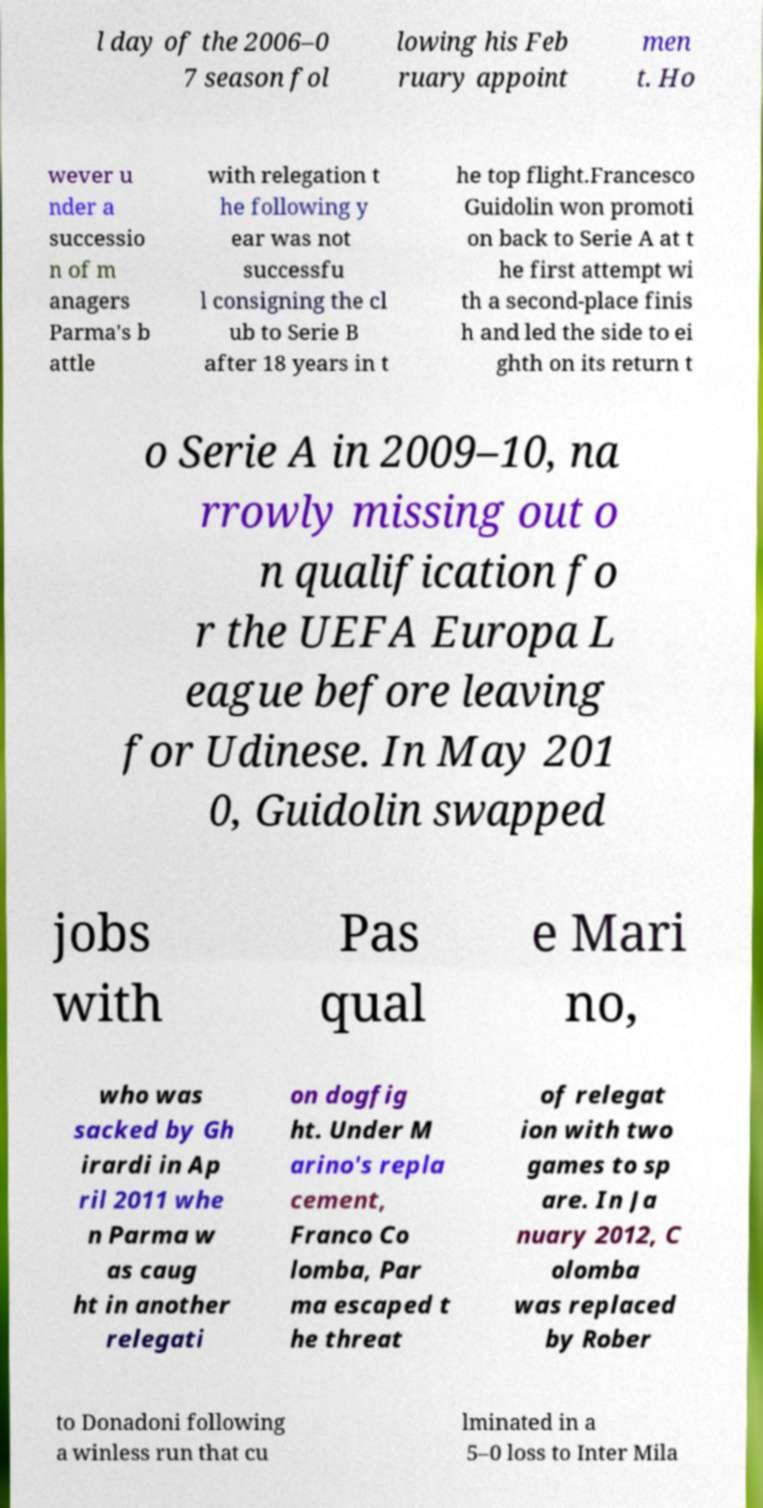Please identify and transcribe the text found in this image. l day of the 2006–0 7 season fol lowing his Feb ruary appoint men t. Ho wever u nder a successio n of m anagers Parma's b attle with relegation t he following y ear was not successfu l consigning the cl ub to Serie B after 18 years in t he top flight.Francesco Guidolin won promoti on back to Serie A at t he first attempt wi th a second-place finis h and led the side to ei ghth on its return t o Serie A in 2009–10, na rrowly missing out o n qualification fo r the UEFA Europa L eague before leaving for Udinese. In May 201 0, Guidolin swapped jobs with Pas qual e Mari no, who was sacked by Gh irardi in Ap ril 2011 whe n Parma w as caug ht in another relegati on dogfig ht. Under M arino's repla cement, Franco Co lomba, Par ma escaped t he threat of relegat ion with two games to sp are. In Ja nuary 2012, C olomba was replaced by Rober to Donadoni following a winless run that cu lminated in a 5–0 loss to Inter Mila 